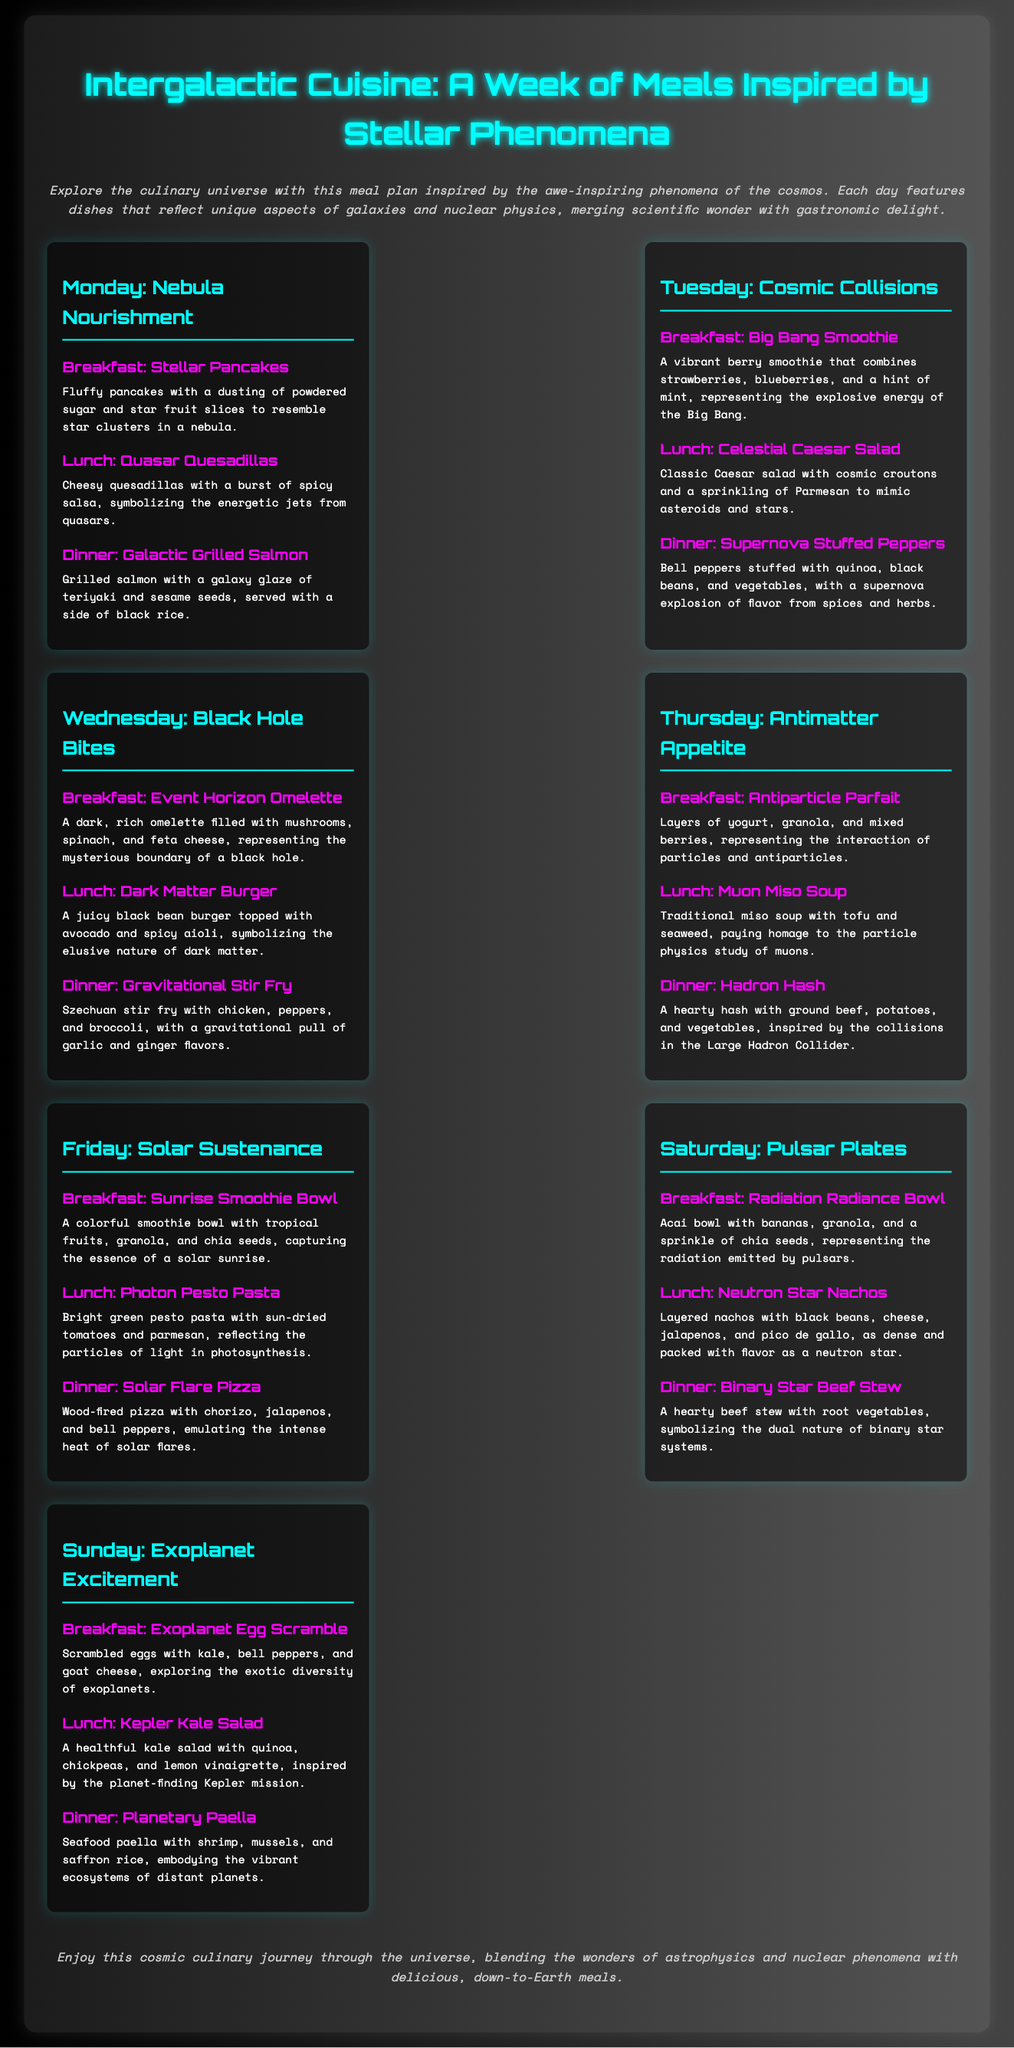What is the theme of the meal plan? The meal plan is themed around culinary dishes inspired by astronomical phenomena and concepts from astrophysics and nuclear physics.
Answer: Intergalactic Cuisine How many days does the meal plan cover? The document outlines meals for each day of the week, specifically seven days.
Answer: Seven days What is served for breakfast on Tuesday? The breakfast option for Tuesday is a smoothie that captures an explosive event in the universe.
Answer: Big Bang Smoothie Which meal represents a black bean burger? The document describes a specific lunch meal that symbolizes the elusive nature of dark matter.
Answer: Dark Matter Burger What unique food item is featured in the Sunday dinner? The Sunday dinner includes a dish that features seafood and rice, embodying the essence of distant planets.
Answer: Planetary Paella What cooking technique is mentioned for Friday's dinner? The Friday dinner is prepared using a specific method associated with high heat and a wood-burning oven.
Answer: Wood-fired pizza Which day features a quinoa-based dish? A quinoa dish is highlighted in a lunch meal served on Thursday.
Answer: Muon Miso Soup What is the primary color theme of the document? The color scheme includes a gradient transitioning from black to gray, with white lettering.
Answer: Black and gray Which meal represents the concept of binary stars? Among the Saturday options, there is a dinner meal that signifies the dual nature of certain astronomical entities.
Answer: Binary Star Beef Stew 